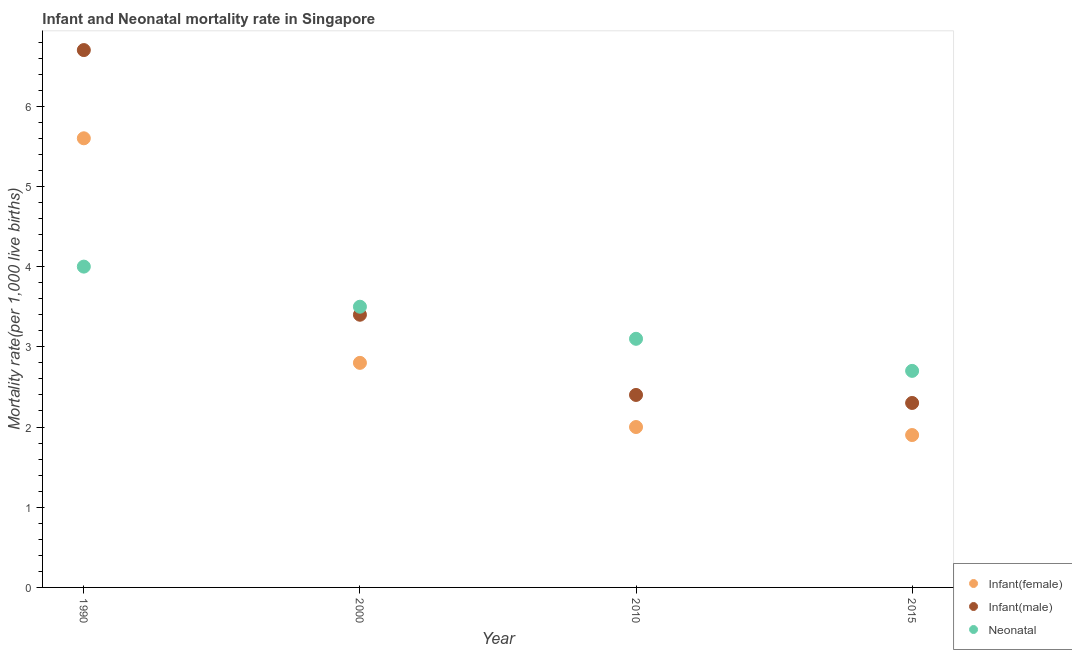Is the number of dotlines equal to the number of legend labels?
Ensure brevity in your answer.  Yes. What is the infant mortality rate(male) in 2015?
Keep it short and to the point. 2.3. In which year was the infant mortality rate(female) maximum?
Your response must be concise. 1990. In which year was the infant mortality rate(male) minimum?
Provide a short and direct response. 2015. What is the difference between the neonatal mortality rate in 2000 and that in 2015?
Make the answer very short. 0.8. What is the difference between the neonatal mortality rate in 1990 and the infant mortality rate(male) in 2015?
Offer a very short reply. 1.7. What is the average infant mortality rate(female) per year?
Provide a short and direct response. 3.07. In the year 2000, what is the difference between the infant mortality rate(female) and neonatal mortality rate?
Offer a terse response. -0.7. Is the difference between the infant mortality rate(female) in 1990 and 2010 greater than the difference between the neonatal mortality rate in 1990 and 2010?
Provide a short and direct response. Yes. What is the difference between the highest and the second highest infant mortality rate(male)?
Give a very brief answer. 3.3. What is the difference between the highest and the lowest neonatal mortality rate?
Provide a short and direct response. 1.3. In how many years, is the infant mortality rate(male) greater than the average infant mortality rate(male) taken over all years?
Give a very brief answer. 1. Is it the case that in every year, the sum of the infant mortality rate(female) and infant mortality rate(male) is greater than the neonatal mortality rate?
Your answer should be very brief. Yes. Is the neonatal mortality rate strictly greater than the infant mortality rate(male) over the years?
Offer a terse response. No. How many dotlines are there?
Make the answer very short. 3. What is the difference between two consecutive major ticks on the Y-axis?
Make the answer very short. 1. How are the legend labels stacked?
Ensure brevity in your answer.  Vertical. What is the title of the graph?
Your response must be concise. Infant and Neonatal mortality rate in Singapore. What is the label or title of the Y-axis?
Offer a terse response. Mortality rate(per 1,0 live births). What is the Mortality rate(per 1,000 live births) in Neonatal  in 1990?
Your answer should be very brief. 4. What is the Mortality rate(per 1,000 live births) of Infant(female) in 2000?
Offer a terse response. 2.8. What is the Mortality rate(per 1,000 live births) of Neonatal  in 2000?
Offer a very short reply. 3.5. What is the Mortality rate(per 1,000 live births) of Infant(female) in 2010?
Provide a short and direct response. 2. What is the Mortality rate(per 1,000 live births) in Infant(male) in 2010?
Offer a terse response. 2.4. What is the Mortality rate(per 1,000 live births) of Neonatal  in 2010?
Offer a very short reply. 3.1. Across all years, what is the maximum Mortality rate(per 1,000 live births) of Infant(female)?
Your response must be concise. 5.6. Across all years, what is the maximum Mortality rate(per 1,000 live births) of Infant(male)?
Provide a short and direct response. 6.7. Across all years, what is the minimum Mortality rate(per 1,000 live births) of Neonatal ?
Offer a terse response. 2.7. What is the total Mortality rate(per 1,000 live births) of Infant(female) in the graph?
Offer a terse response. 12.3. What is the total Mortality rate(per 1,000 live births) of Infant(male) in the graph?
Provide a succinct answer. 14.8. What is the total Mortality rate(per 1,000 live births) in Neonatal  in the graph?
Ensure brevity in your answer.  13.3. What is the difference between the Mortality rate(per 1,000 live births) of Infant(female) in 1990 and that in 2000?
Provide a short and direct response. 2.8. What is the difference between the Mortality rate(per 1,000 live births) in Infant(male) in 1990 and that in 2000?
Provide a short and direct response. 3.3. What is the difference between the Mortality rate(per 1,000 live births) of Infant(male) in 1990 and that in 2015?
Offer a terse response. 4.4. What is the difference between the Mortality rate(per 1,000 live births) in Infant(female) in 2000 and that in 2010?
Offer a terse response. 0.8. What is the difference between the Mortality rate(per 1,000 live births) in Infant(male) in 2000 and that in 2010?
Your answer should be very brief. 1. What is the difference between the Mortality rate(per 1,000 live births) of Neonatal  in 2000 and that in 2010?
Make the answer very short. 0.4. What is the difference between the Mortality rate(per 1,000 live births) in Neonatal  in 2000 and that in 2015?
Provide a succinct answer. 0.8. What is the difference between the Mortality rate(per 1,000 live births) in Neonatal  in 2010 and that in 2015?
Provide a succinct answer. 0.4. What is the difference between the Mortality rate(per 1,000 live births) in Infant(female) in 1990 and the Mortality rate(per 1,000 live births) in Neonatal  in 2000?
Your response must be concise. 2.1. What is the difference between the Mortality rate(per 1,000 live births) in Infant(male) in 1990 and the Mortality rate(per 1,000 live births) in Neonatal  in 2010?
Your response must be concise. 3.6. What is the difference between the Mortality rate(per 1,000 live births) in Infant(female) in 1990 and the Mortality rate(per 1,000 live births) in Infant(male) in 2015?
Offer a terse response. 3.3. What is the difference between the Mortality rate(per 1,000 live births) of Infant(female) in 1990 and the Mortality rate(per 1,000 live births) of Neonatal  in 2015?
Provide a succinct answer. 2.9. What is the difference between the Mortality rate(per 1,000 live births) in Infant(male) in 1990 and the Mortality rate(per 1,000 live births) in Neonatal  in 2015?
Ensure brevity in your answer.  4. What is the difference between the Mortality rate(per 1,000 live births) of Infant(female) in 2000 and the Mortality rate(per 1,000 live births) of Infant(male) in 2010?
Give a very brief answer. 0.4. What is the difference between the Mortality rate(per 1,000 live births) in Infant(male) in 2010 and the Mortality rate(per 1,000 live births) in Neonatal  in 2015?
Offer a very short reply. -0.3. What is the average Mortality rate(per 1,000 live births) in Infant(female) per year?
Offer a very short reply. 3.08. What is the average Mortality rate(per 1,000 live births) of Infant(male) per year?
Offer a terse response. 3.7. What is the average Mortality rate(per 1,000 live births) of Neonatal  per year?
Provide a short and direct response. 3.33. In the year 1990, what is the difference between the Mortality rate(per 1,000 live births) in Infant(female) and Mortality rate(per 1,000 live births) in Infant(male)?
Provide a short and direct response. -1.1. In the year 1990, what is the difference between the Mortality rate(per 1,000 live births) of Infant(male) and Mortality rate(per 1,000 live births) of Neonatal ?
Make the answer very short. 2.7. In the year 2000, what is the difference between the Mortality rate(per 1,000 live births) of Infant(female) and Mortality rate(per 1,000 live births) of Neonatal ?
Make the answer very short. -0.7. In the year 2000, what is the difference between the Mortality rate(per 1,000 live births) of Infant(male) and Mortality rate(per 1,000 live births) of Neonatal ?
Give a very brief answer. -0.1. In the year 2010, what is the difference between the Mortality rate(per 1,000 live births) of Infant(female) and Mortality rate(per 1,000 live births) of Neonatal ?
Give a very brief answer. -1.1. In the year 2015, what is the difference between the Mortality rate(per 1,000 live births) of Infant(female) and Mortality rate(per 1,000 live births) of Infant(male)?
Your answer should be very brief. -0.4. In the year 2015, what is the difference between the Mortality rate(per 1,000 live births) in Infant(female) and Mortality rate(per 1,000 live births) in Neonatal ?
Provide a succinct answer. -0.8. In the year 2015, what is the difference between the Mortality rate(per 1,000 live births) of Infant(male) and Mortality rate(per 1,000 live births) of Neonatal ?
Offer a very short reply. -0.4. What is the ratio of the Mortality rate(per 1,000 live births) in Infant(female) in 1990 to that in 2000?
Offer a terse response. 2. What is the ratio of the Mortality rate(per 1,000 live births) in Infant(male) in 1990 to that in 2000?
Ensure brevity in your answer.  1.97. What is the ratio of the Mortality rate(per 1,000 live births) in Infant(male) in 1990 to that in 2010?
Offer a terse response. 2.79. What is the ratio of the Mortality rate(per 1,000 live births) in Neonatal  in 1990 to that in 2010?
Your answer should be very brief. 1.29. What is the ratio of the Mortality rate(per 1,000 live births) of Infant(female) in 1990 to that in 2015?
Keep it short and to the point. 2.95. What is the ratio of the Mortality rate(per 1,000 live births) in Infant(male) in 1990 to that in 2015?
Give a very brief answer. 2.91. What is the ratio of the Mortality rate(per 1,000 live births) of Neonatal  in 1990 to that in 2015?
Make the answer very short. 1.48. What is the ratio of the Mortality rate(per 1,000 live births) of Infant(female) in 2000 to that in 2010?
Provide a short and direct response. 1.4. What is the ratio of the Mortality rate(per 1,000 live births) in Infant(male) in 2000 to that in 2010?
Give a very brief answer. 1.42. What is the ratio of the Mortality rate(per 1,000 live births) in Neonatal  in 2000 to that in 2010?
Your answer should be very brief. 1.13. What is the ratio of the Mortality rate(per 1,000 live births) in Infant(female) in 2000 to that in 2015?
Give a very brief answer. 1.47. What is the ratio of the Mortality rate(per 1,000 live births) of Infant(male) in 2000 to that in 2015?
Ensure brevity in your answer.  1.48. What is the ratio of the Mortality rate(per 1,000 live births) of Neonatal  in 2000 to that in 2015?
Make the answer very short. 1.3. What is the ratio of the Mortality rate(per 1,000 live births) of Infant(female) in 2010 to that in 2015?
Provide a short and direct response. 1.05. What is the ratio of the Mortality rate(per 1,000 live births) in Infant(male) in 2010 to that in 2015?
Your answer should be very brief. 1.04. What is the ratio of the Mortality rate(per 1,000 live births) of Neonatal  in 2010 to that in 2015?
Provide a short and direct response. 1.15. What is the difference between the highest and the second highest Mortality rate(per 1,000 live births) in Infant(female)?
Ensure brevity in your answer.  2.8. 